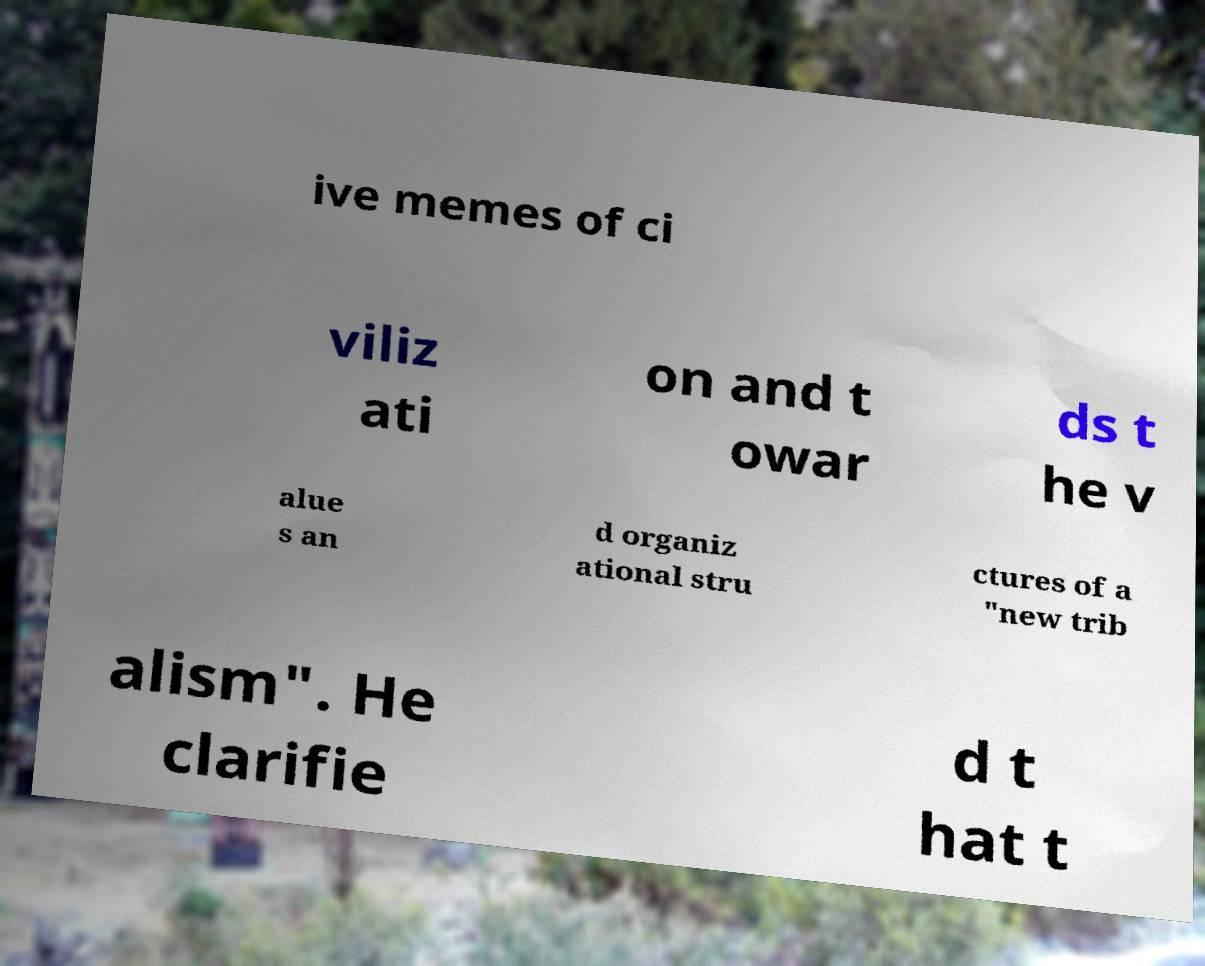Can you accurately transcribe the text from the provided image for me? ive memes of ci viliz ati on and t owar ds t he v alue s an d organiz ational stru ctures of a "new trib alism". He clarifie d t hat t 